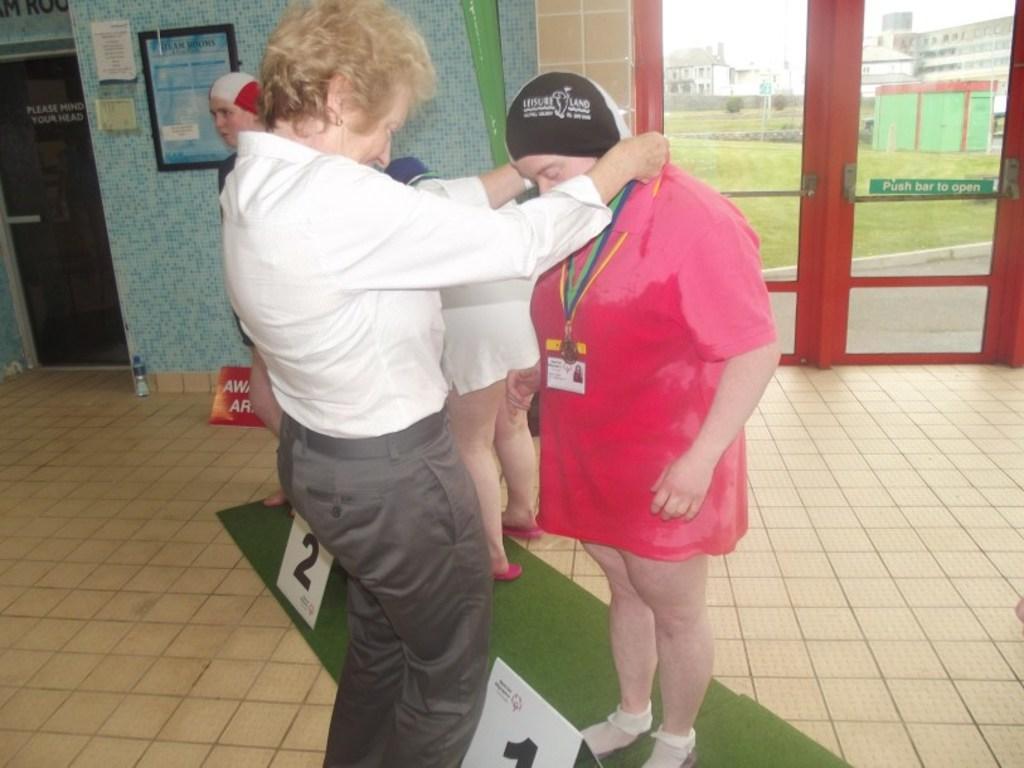Please provide a concise description of this image. In this image, we can see some people standing, there is a glass door, there is a wall, in the background there is green grass on the ground. 